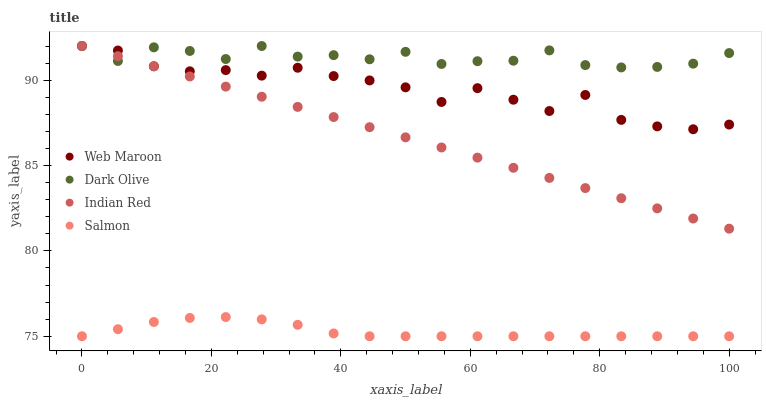Does Salmon have the minimum area under the curve?
Answer yes or no. Yes. Does Dark Olive have the maximum area under the curve?
Answer yes or no. Yes. Does Web Maroon have the minimum area under the curve?
Answer yes or no. No. Does Web Maroon have the maximum area under the curve?
Answer yes or no. No. Is Indian Red the smoothest?
Answer yes or no. Yes. Is Web Maroon the roughest?
Answer yes or no. Yes. Is Dark Olive the smoothest?
Answer yes or no. No. Is Dark Olive the roughest?
Answer yes or no. No. Does Salmon have the lowest value?
Answer yes or no. Yes. Does Web Maroon have the lowest value?
Answer yes or no. No. Does Indian Red have the highest value?
Answer yes or no. Yes. Is Salmon less than Dark Olive?
Answer yes or no. Yes. Is Dark Olive greater than Salmon?
Answer yes or no. Yes. Does Indian Red intersect Web Maroon?
Answer yes or no. Yes. Is Indian Red less than Web Maroon?
Answer yes or no. No. Is Indian Red greater than Web Maroon?
Answer yes or no. No. Does Salmon intersect Dark Olive?
Answer yes or no. No. 